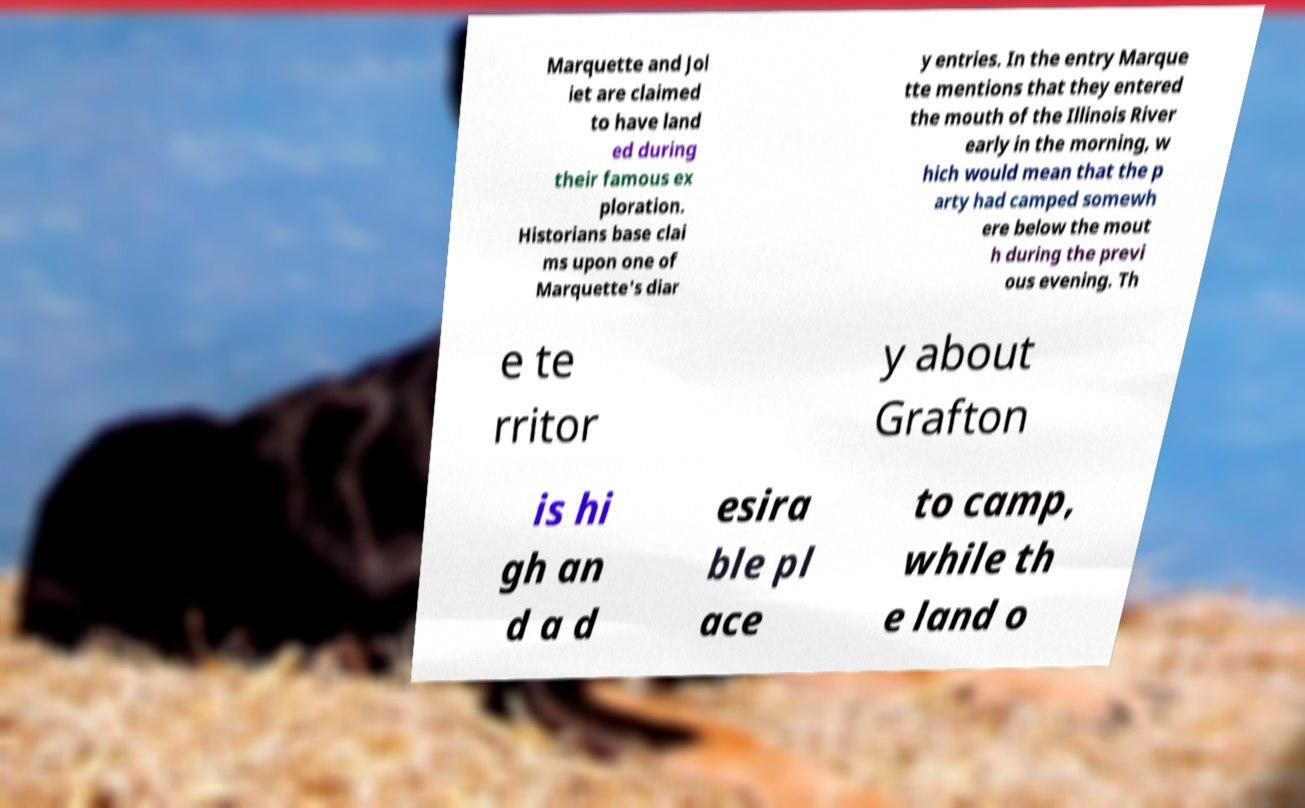There's text embedded in this image that I need extracted. Can you transcribe it verbatim? Marquette and Jol iet are claimed to have land ed during their famous ex ploration. Historians base clai ms upon one of Marquette's diar y entries. In the entry Marque tte mentions that they entered the mouth of the Illinois River early in the morning, w hich would mean that the p arty had camped somewh ere below the mout h during the previ ous evening. Th e te rritor y about Grafton is hi gh an d a d esira ble pl ace to camp, while th e land o 